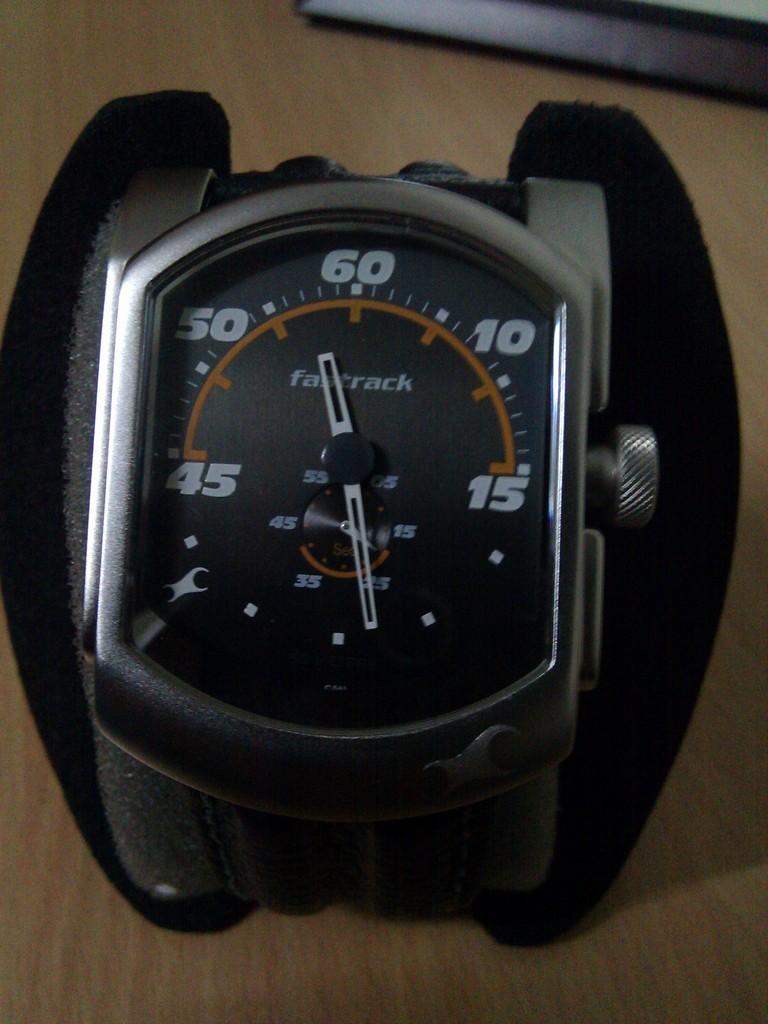What time is displayed on the watch?
Provide a short and direct response. 11:28. 